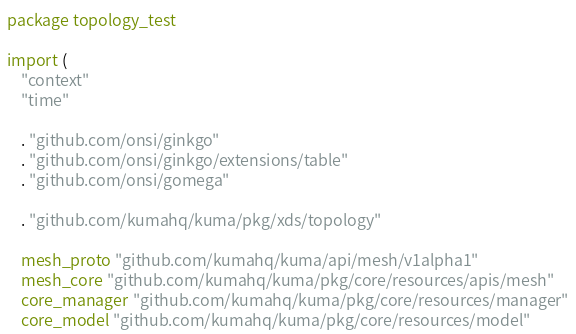<code> <loc_0><loc_0><loc_500><loc_500><_Go_>package topology_test

import (
	"context"
	"time"

	. "github.com/onsi/ginkgo"
	. "github.com/onsi/ginkgo/extensions/table"
	. "github.com/onsi/gomega"

	. "github.com/kumahq/kuma/pkg/xds/topology"

	mesh_proto "github.com/kumahq/kuma/api/mesh/v1alpha1"
	mesh_core "github.com/kumahq/kuma/pkg/core/resources/apis/mesh"
	core_manager "github.com/kumahq/kuma/pkg/core/resources/manager"
	core_model "github.com/kumahq/kuma/pkg/core/resources/model"</code> 